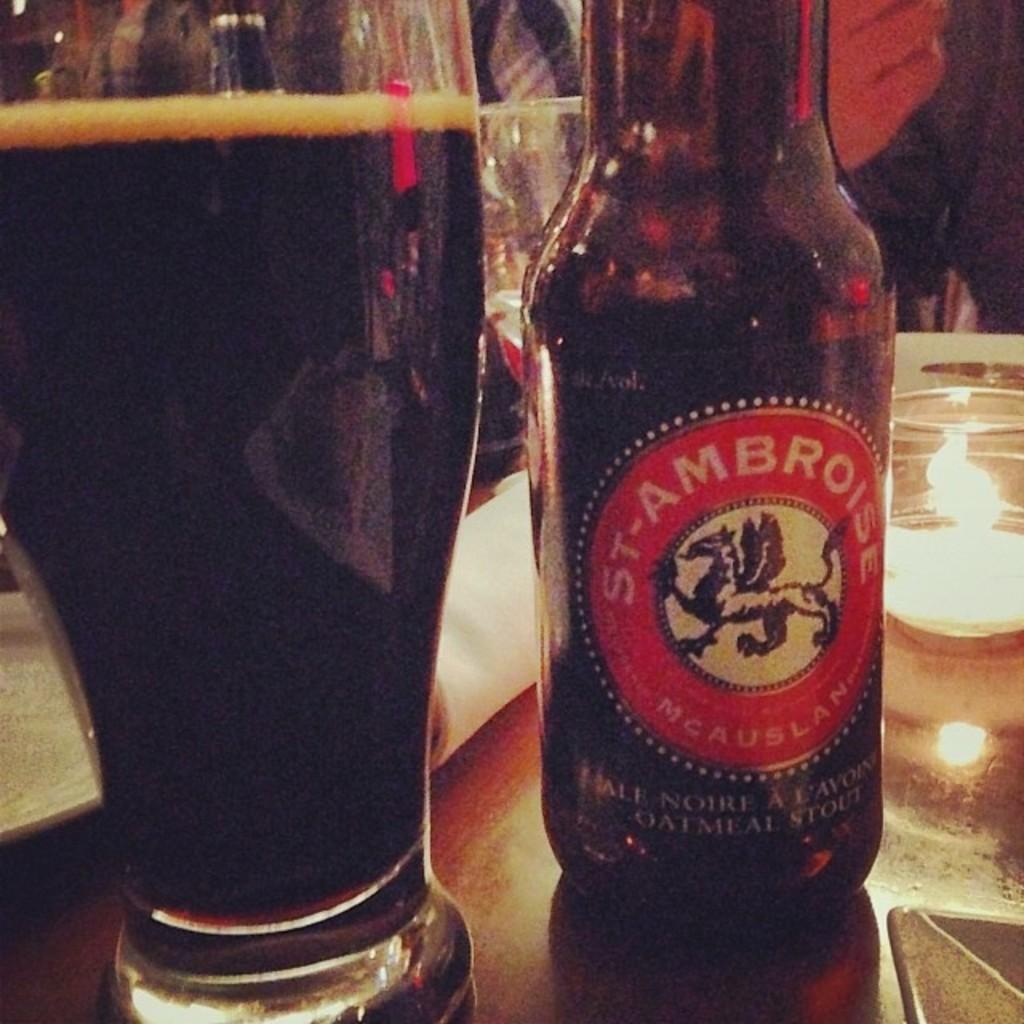In one or two sentences, can you explain what this image depicts? In this image I can see a bottle, glasses and other objects on the table. In the background I can see a person's hand. 